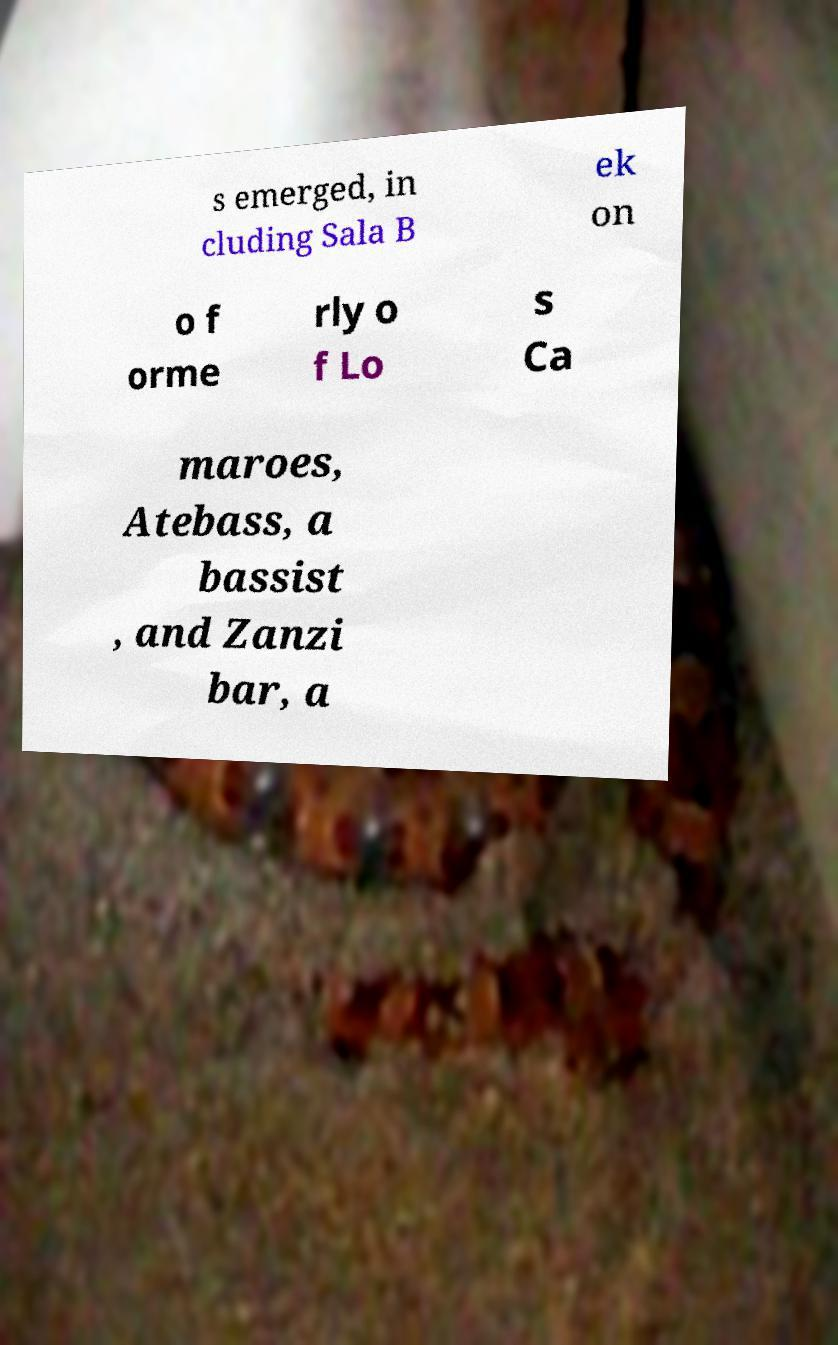Could you assist in decoding the text presented in this image and type it out clearly? s emerged, in cluding Sala B ek on o f orme rly o f Lo s Ca maroes, Atebass, a bassist , and Zanzi bar, a 